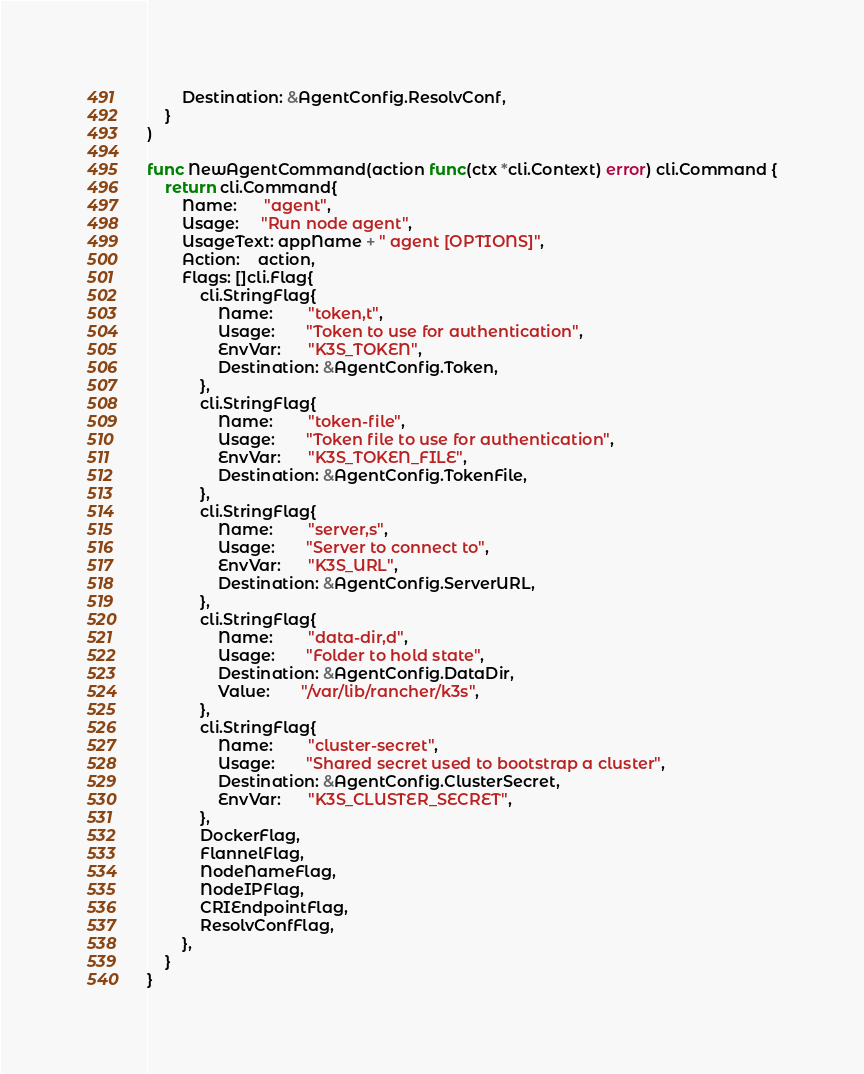<code> <loc_0><loc_0><loc_500><loc_500><_Go_>		Destination: &AgentConfig.ResolvConf,
	}
)

func NewAgentCommand(action func(ctx *cli.Context) error) cli.Command {
	return cli.Command{
		Name:      "agent",
		Usage:     "Run node agent",
		UsageText: appName + " agent [OPTIONS]",
		Action:    action,
		Flags: []cli.Flag{
			cli.StringFlag{
				Name:        "token,t",
				Usage:       "Token to use for authentication",
				EnvVar:      "K3S_TOKEN",
				Destination: &AgentConfig.Token,
			},
			cli.StringFlag{
				Name:        "token-file",
				Usage:       "Token file to use for authentication",
				EnvVar:      "K3S_TOKEN_FILE",
				Destination: &AgentConfig.TokenFile,
			},
			cli.StringFlag{
				Name:        "server,s",
				Usage:       "Server to connect to",
				EnvVar:      "K3S_URL",
				Destination: &AgentConfig.ServerURL,
			},
			cli.StringFlag{
				Name:        "data-dir,d",
				Usage:       "Folder to hold state",
				Destination: &AgentConfig.DataDir,
				Value:       "/var/lib/rancher/k3s",
			},
			cli.StringFlag{
				Name:        "cluster-secret",
				Usage:       "Shared secret used to bootstrap a cluster",
				Destination: &AgentConfig.ClusterSecret,
				EnvVar:      "K3S_CLUSTER_SECRET",
			},
			DockerFlag,
			FlannelFlag,
			NodeNameFlag,
			NodeIPFlag,
			CRIEndpointFlag,
			ResolvConfFlag,
		},
	}
}
</code> 